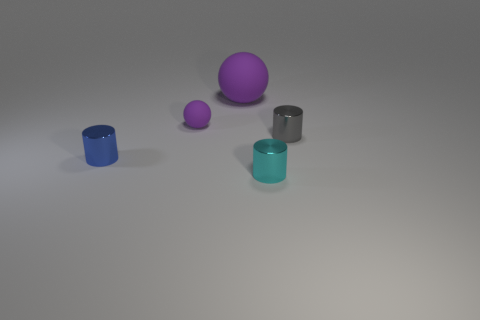There is a big matte ball; does it have the same color as the small thing behind the tiny gray metallic object?
Ensure brevity in your answer.  Yes. There is a gray thing that is the same shape as the small cyan object; what is its material?
Provide a short and direct response. Metal. There is a thing that is right of the tiny purple sphere and on the left side of the small cyan cylinder; what is its material?
Provide a succinct answer. Rubber. How many other things have the same shape as the blue object?
Offer a very short reply. 2. There is a small object that is behind the shiny cylinder that is behind the small blue metal object; what color is it?
Keep it short and to the point. Purple. Is the number of cyan metal things behind the small rubber sphere the same as the number of yellow matte cylinders?
Give a very brief answer. Yes. Are there any cyan metallic things that have the same size as the blue cylinder?
Offer a very short reply. Yes. There is a blue cylinder; is it the same size as the object that is behind the tiny ball?
Offer a terse response. No. Are there an equal number of big matte objects that are behind the large matte ball and spheres that are on the right side of the small rubber sphere?
Keep it short and to the point. No. What is the purple object in front of the large purple rubber object made of?
Your answer should be compact. Rubber. 